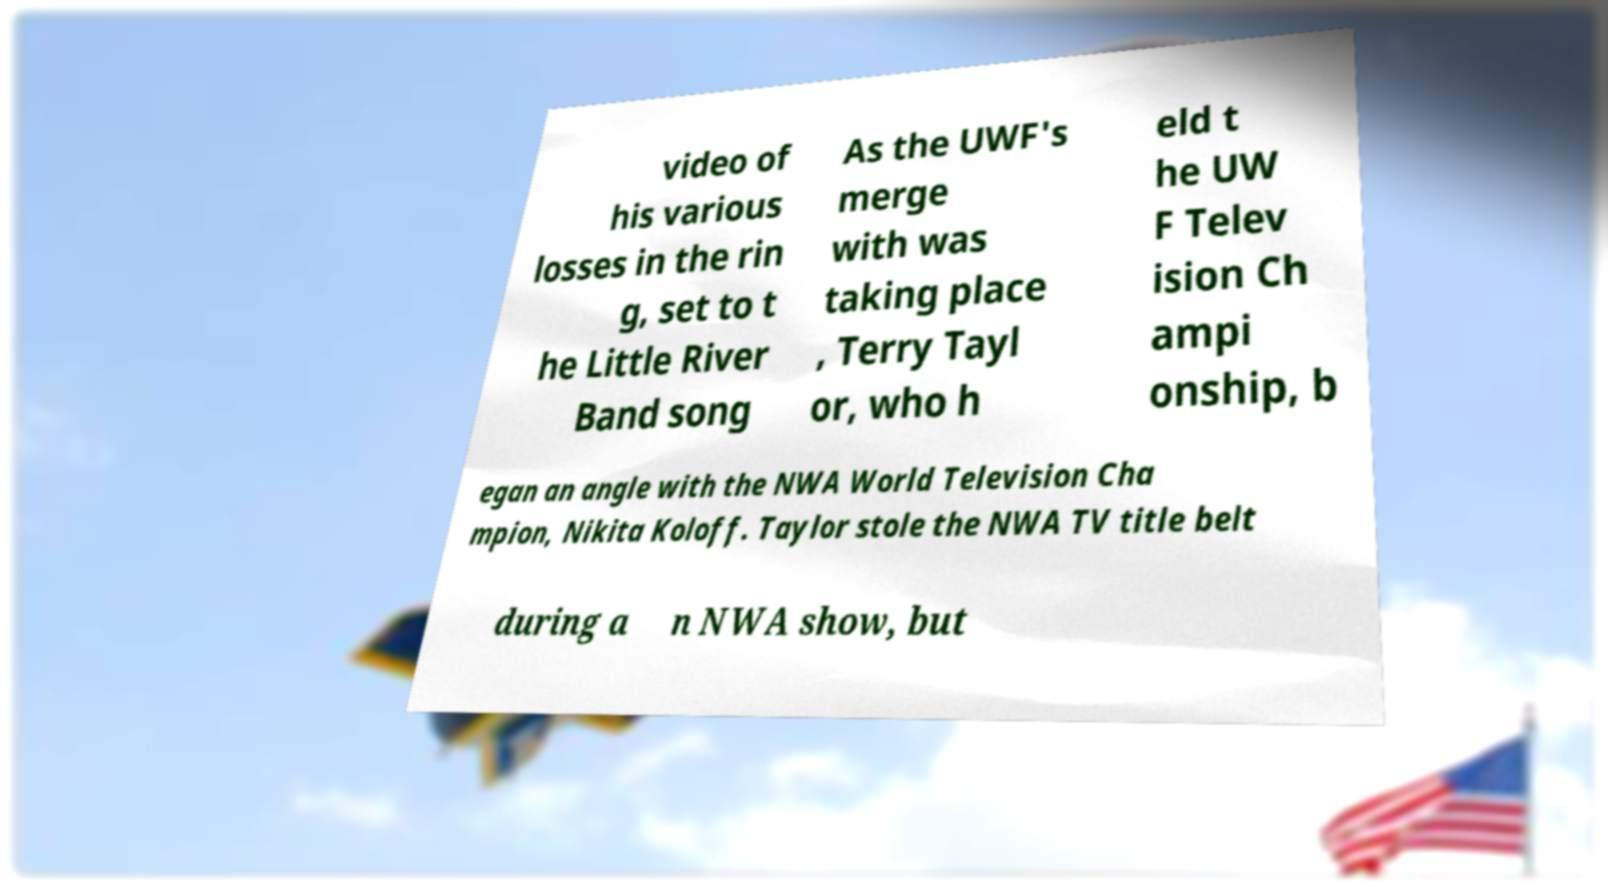There's text embedded in this image that I need extracted. Can you transcribe it verbatim? video of his various losses in the rin g, set to t he Little River Band song As the UWF's merge with was taking place , Terry Tayl or, who h eld t he UW F Telev ision Ch ampi onship, b egan an angle with the NWA World Television Cha mpion, Nikita Koloff. Taylor stole the NWA TV title belt during a n NWA show, but 